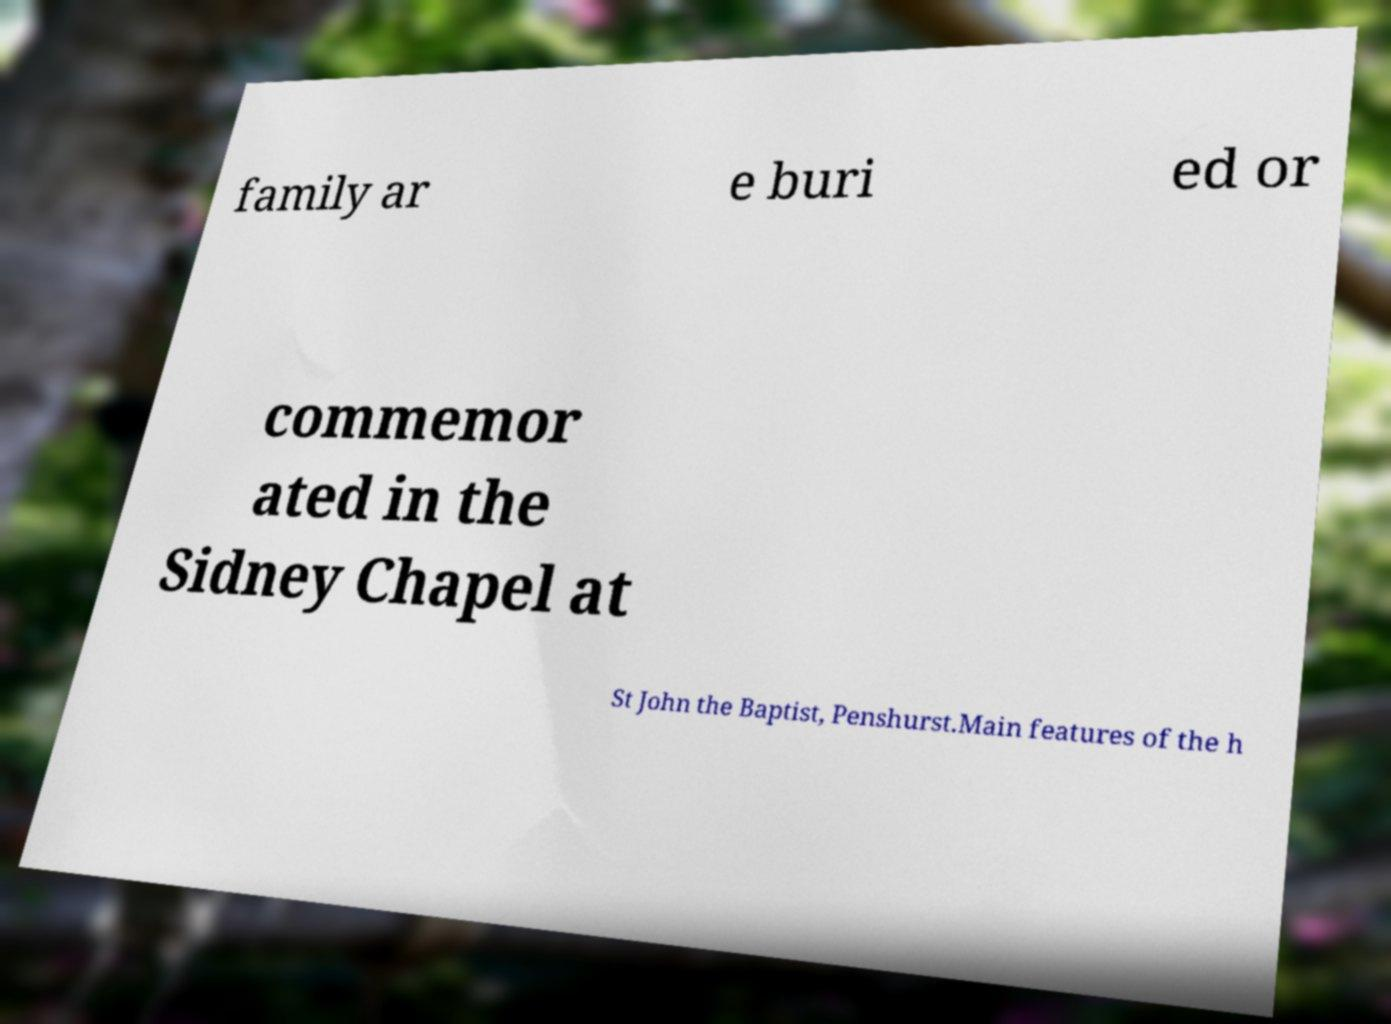What messages or text are displayed in this image? I need them in a readable, typed format. family ar e buri ed or commemor ated in the Sidney Chapel at St John the Baptist, Penshurst.Main features of the h 